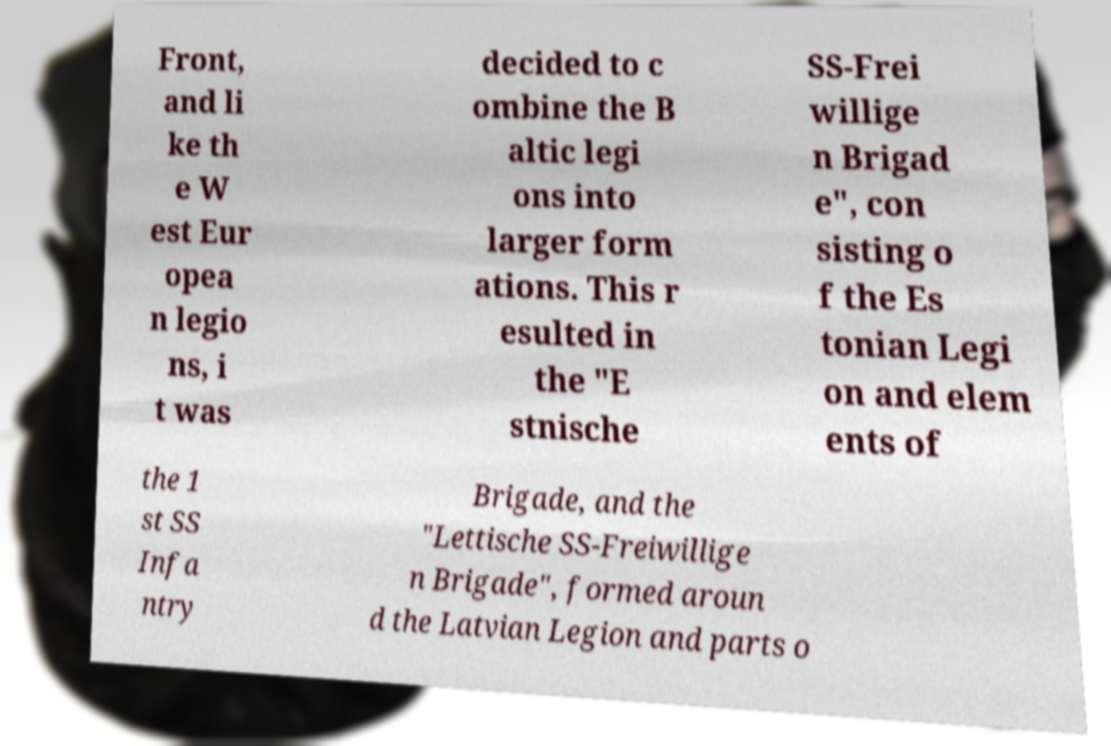Please read and relay the text visible in this image. What does it say? Front, and li ke th e W est Eur opea n legio ns, i t was decided to c ombine the B altic legi ons into larger form ations. This r esulted in the "E stnische SS-Frei willige n Brigad e", con sisting o f the Es tonian Legi on and elem ents of the 1 st SS Infa ntry Brigade, and the "Lettische SS-Freiwillige n Brigade", formed aroun d the Latvian Legion and parts o 